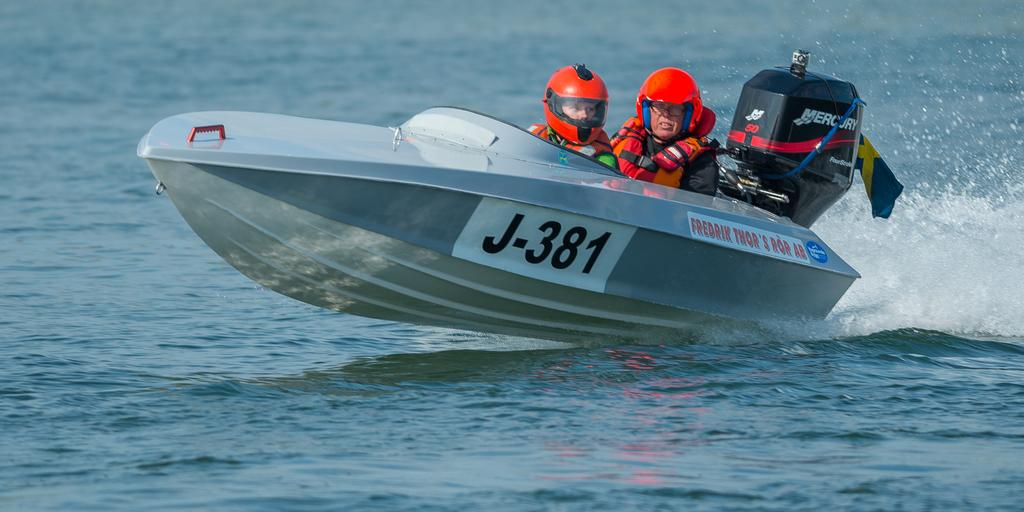How many people are in the image? There are two people in the image. What activity are the people engaged in? The two people are boating. Where is the boating taking place? The boating is taking place on the water. What type of tax is being discussed by the people in the image? There is no indication in the image that the people are discussing any type of tax. 